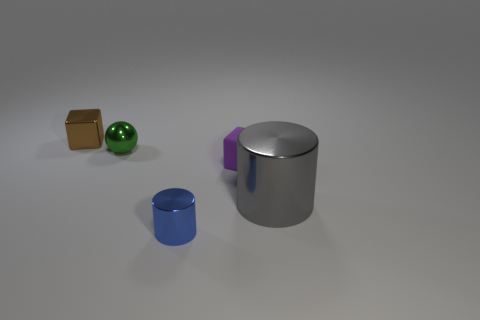Add 1 tiny blue metal things. How many objects exist? 6 Subtract all purple cubes. How many cubes are left? 1 Subtract 0 cyan cylinders. How many objects are left? 5 Subtract all cubes. How many objects are left? 3 Subtract 1 balls. How many balls are left? 0 Subtract all green cubes. Subtract all green spheres. How many cubes are left? 2 Subtract all red balls. How many brown blocks are left? 1 Subtract all rubber objects. Subtract all purple matte blocks. How many objects are left? 3 Add 5 tiny rubber things. How many tiny rubber things are left? 6 Add 5 green spheres. How many green spheres exist? 6 